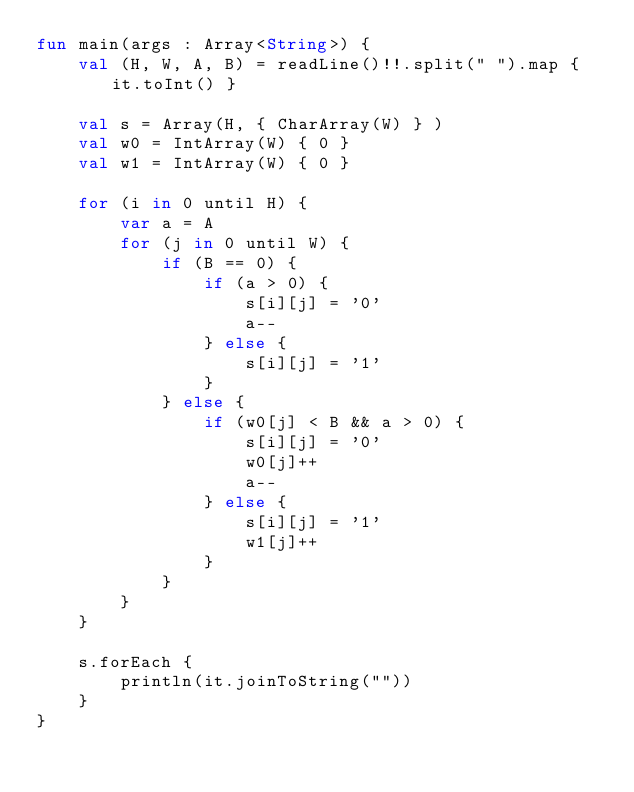Convert code to text. <code><loc_0><loc_0><loc_500><loc_500><_Kotlin_>fun main(args : Array<String>) {
    val (H, W, A, B) = readLine()!!.split(" ").map { it.toInt() }

    val s = Array(H, { CharArray(W) } )
    val w0 = IntArray(W) { 0 }
    val w1 = IntArray(W) { 0 }

    for (i in 0 until H) {
        var a = A
        for (j in 0 until W) {
            if (B == 0) {
                if (a > 0) {
                    s[i][j] = '0'
                    a--
                } else {
                    s[i][j] = '1'
                }
            } else {
                if (w0[j] < B && a > 0) {
                    s[i][j] = '0'
                    w0[j]++
                    a--
                } else {
                    s[i][j] = '1'
                    w1[j]++
                }
            }
        }
    }

    s.forEach {
        println(it.joinToString(""))
    }
}
</code> 